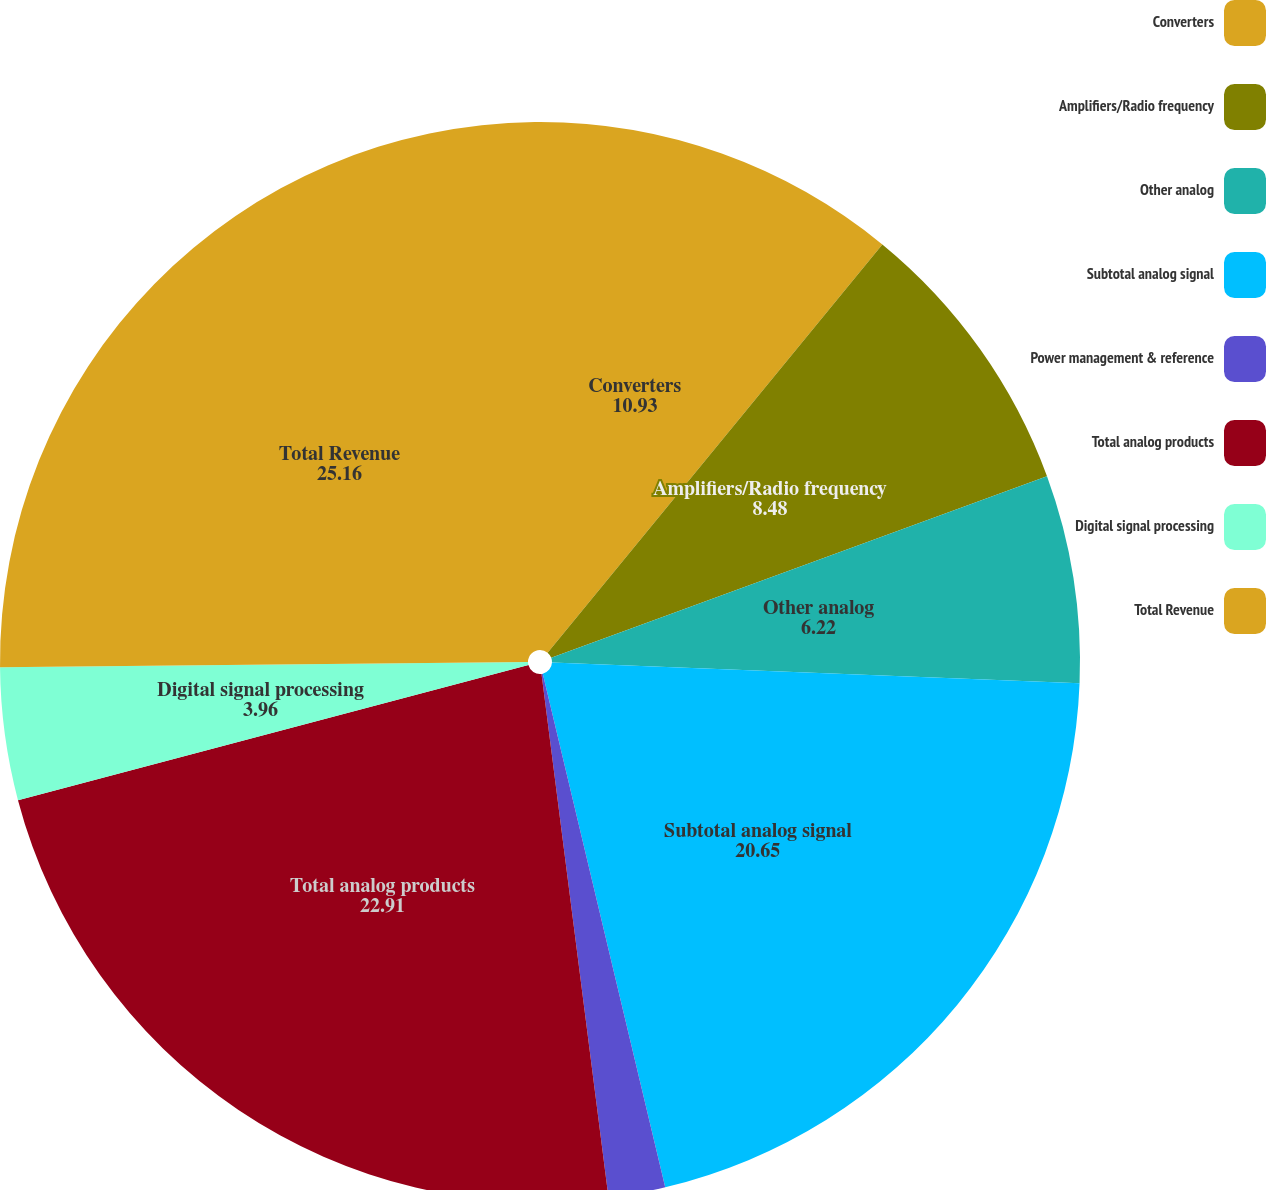<chart> <loc_0><loc_0><loc_500><loc_500><pie_chart><fcel>Converters<fcel>Amplifiers/Radio frequency<fcel>Other analog<fcel>Subtotal analog signal<fcel>Power management & reference<fcel>Total analog products<fcel>Digital signal processing<fcel>Total Revenue<nl><fcel>10.93%<fcel>8.48%<fcel>6.22%<fcel>20.65%<fcel>1.7%<fcel>22.91%<fcel>3.96%<fcel>25.16%<nl></chart> 